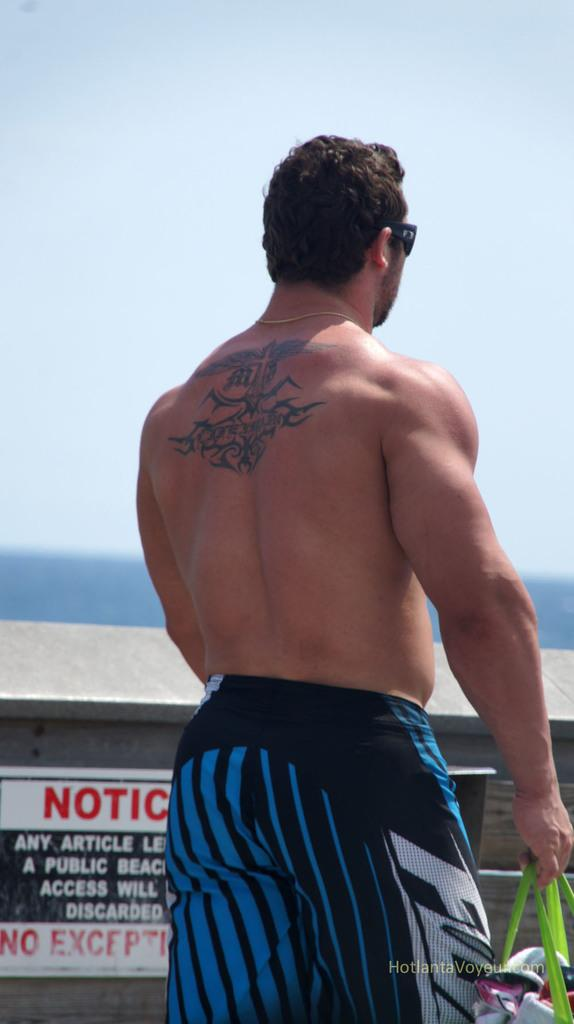<image>
Render a clear and concise summary of the photo. A man in a bathing suit stands in front of a notice sign. 